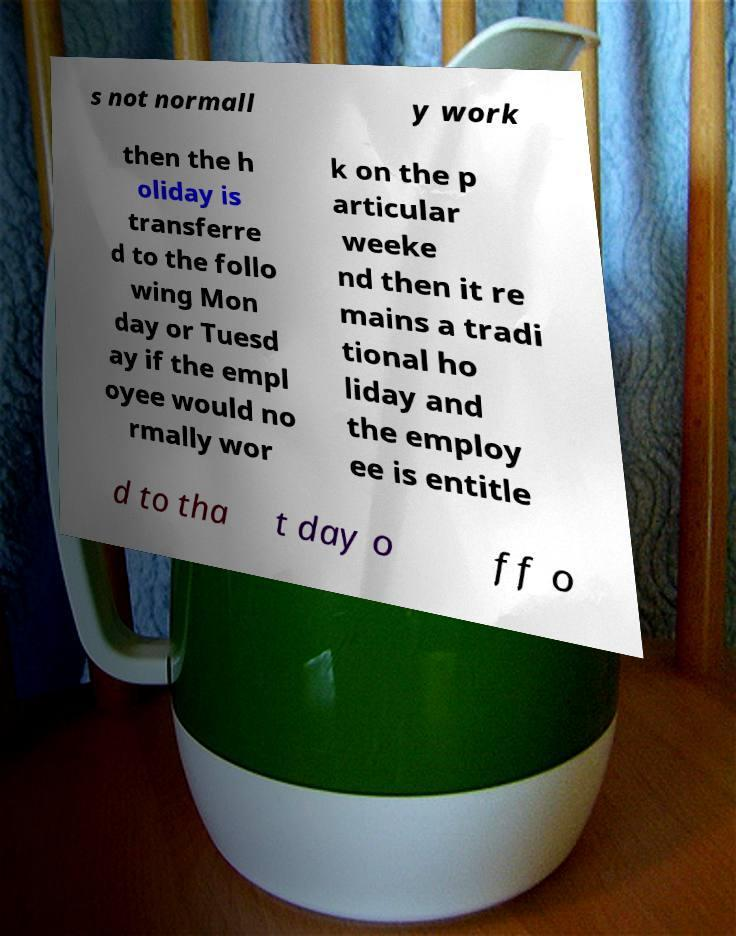There's text embedded in this image that I need extracted. Can you transcribe it verbatim? s not normall y work then the h oliday is transferre d to the follo wing Mon day or Tuesd ay if the empl oyee would no rmally wor k on the p articular weeke nd then it re mains a tradi tional ho liday and the employ ee is entitle d to tha t day o ff o 